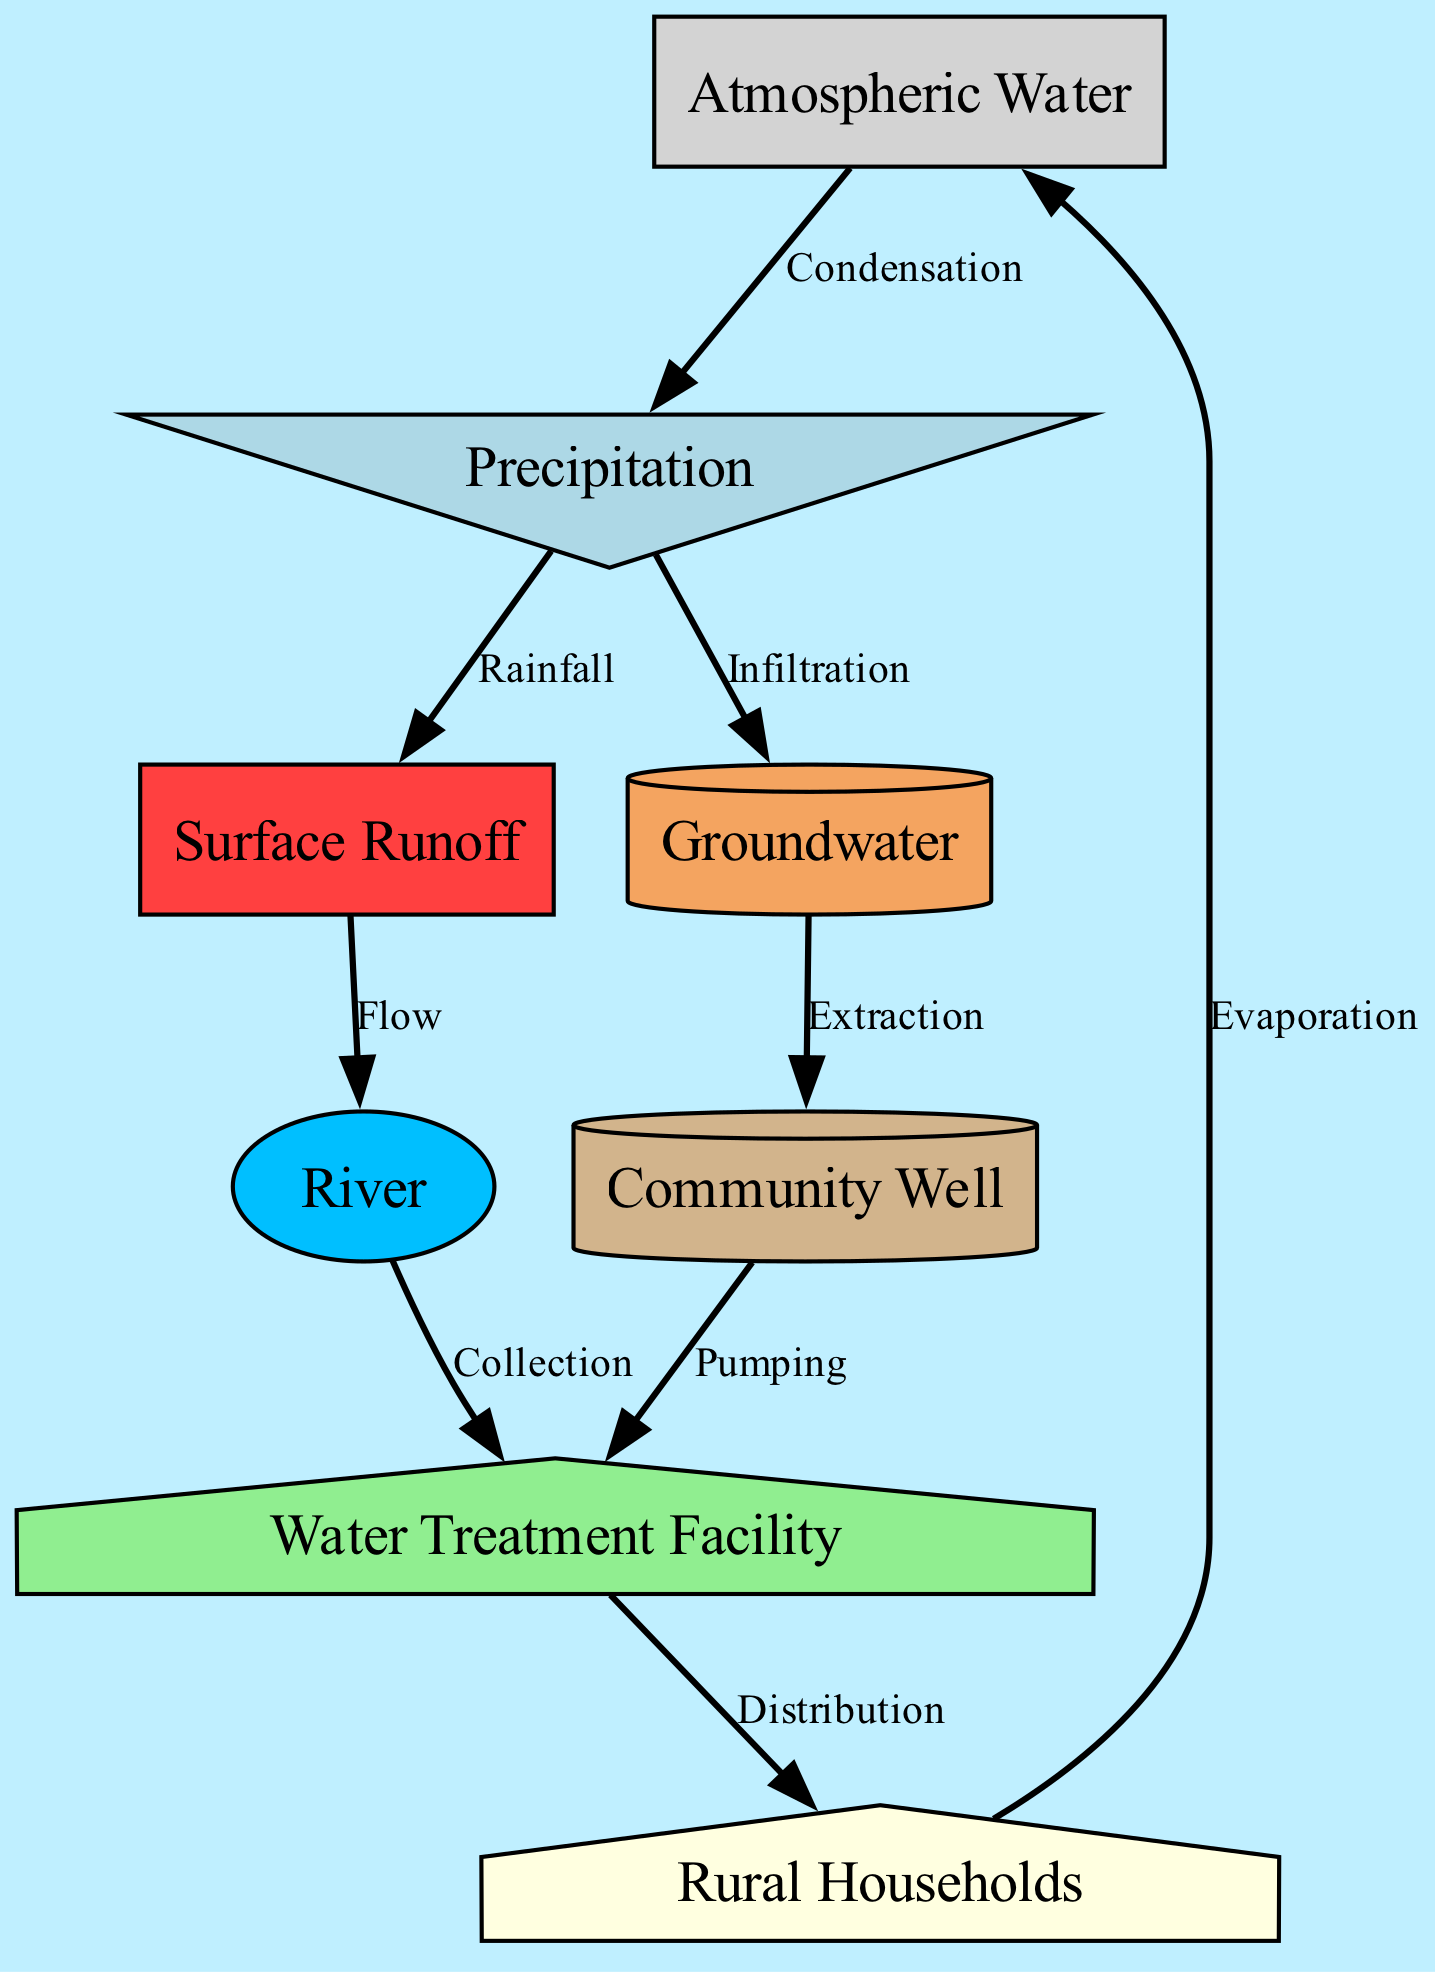What is the first step in the water cycle according to the diagram? The diagram begins with "Atmospheric Water" which transforms into "Precipitation" through the process of "Condensation".
Answer: Atmospheric Water How many connections (edges) are there between nodes in the diagram? Counting all the connecting lines (edges) shown between the nodes reveals there are 8 relationships established within the diagram.
Answer: 8 What process leads to "Surface Runoff"? "Surface Runoff" is a result of "Rainfall", where water precipitates and flows over the ground surface.
Answer: Rainfall Which node is connected to both "River" and "Community Well"? The "Water Treatment Facility" is the node that connects to both the "River" and the "Community Well" as it receives water from these sources.
Answer: Water Treatment Facility What is extracted from "Groundwater" in the diagram? The diagram shows that "Extraction" is the process resulting in water being taken from "Groundwater" to supply the "Community Well".
Answer: Community Well How does "Precipitation" contribute to "Groundwater"? "Precipitation" undergoes a process called "Infiltration", where it seeps into the ground, thus replenishing the "Groundwater".
Answer: Infiltration Which element in the diagram represents rural households? The term "Rural Households" directly refers to the specific node that illustrates the end-users of water in the local ecosystem.
Answer: Rural Households What is the final output of clean water in the cycle? After passing through the "Water Treatment Facility", water is distributed to the "Rural Households", marking the end of the cycle for clean water.
Answer: Rural Households What is the relationship labeled as between "Cloud" and "Rain"? The connection is labeled "Condensation", identifying the process that converts water vapor in clouds into liquid precipitation.
Answer: Condensation 